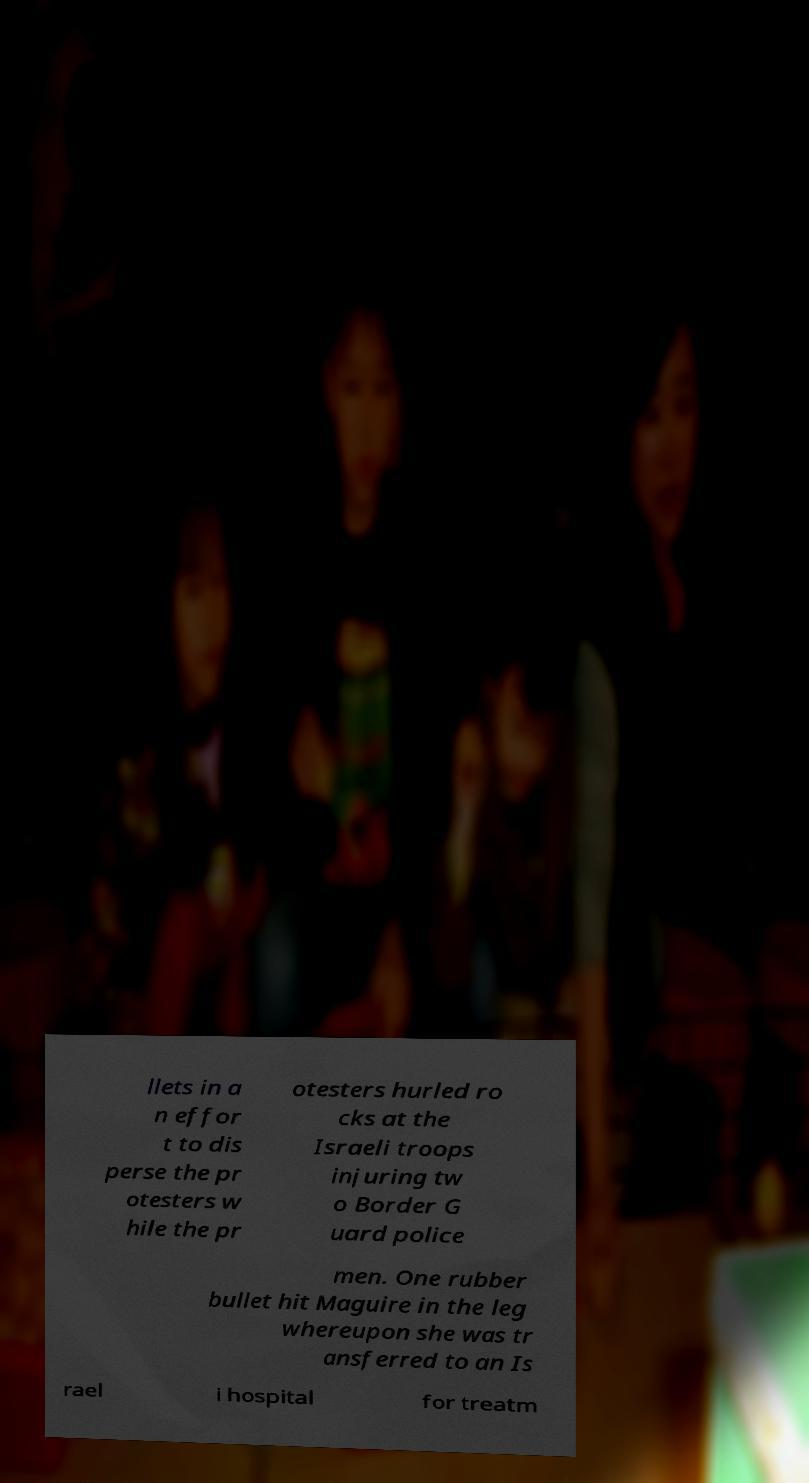I need the written content from this picture converted into text. Can you do that? llets in a n effor t to dis perse the pr otesters w hile the pr otesters hurled ro cks at the Israeli troops injuring tw o Border G uard police men. One rubber bullet hit Maguire in the leg whereupon she was tr ansferred to an Is rael i hospital for treatm 